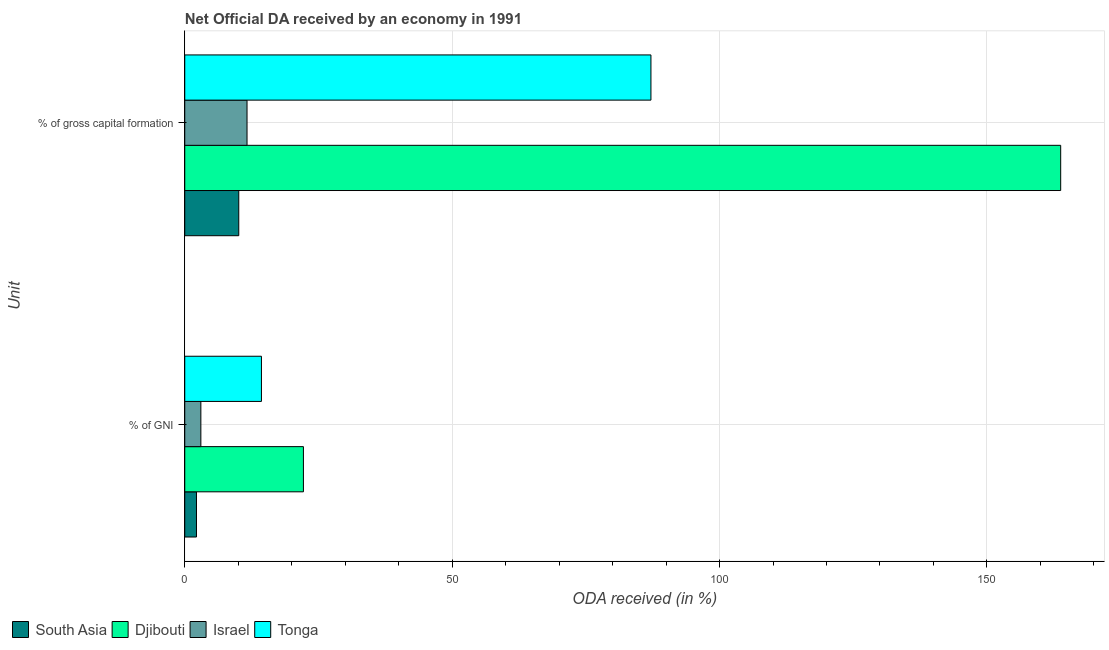How many groups of bars are there?
Offer a terse response. 2. Are the number of bars per tick equal to the number of legend labels?
Provide a succinct answer. Yes. Are the number of bars on each tick of the Y-axis equal?
Ensure brevity in your answer.  Yes. What is the label of the 1st group of bars from the top?
Provide a succinct answer. % of gross capital formation. What is the oda received as percentage of gni in South Asia?
Your answer should be very brief. 2.19. Across all countries, what is the maximum oda received as percentage of gross capital formation?
Your answer should be very brief. 163.8. Across all countries, what is the minimum oda received as percentage of gni?
Keep it short and to the point. 2.19. In which country was the oda received as percentage of gni maximum?
Your answer should be compact. Djibouti. What is the total oda received as percentage of gross capital formation in the graph?
Ensure brevity in your answer.  272.72. What is the difference between the oda received as percentage of gross capital formation in Tonga and that in Israel?
Your answer should be compact. 75.53. What is the difference between the oda received as percentage of gni in South Asia and the oda received as percentage of gross capital formation in Tonga?
Make the answer very short. -84.98. What is the average oda received as percentage of gross capital formation per country?
Offer a very short reply. 68.18. What is the difference between the oda received as percentage of gross capital formation and oda received as percentage of gni in Tonga?
Your response must be concise. 72.83. What is the ratio of the oda received as percentage of gross capital formation in Tonga to that in South Asia?
Make the answer very short. 8.63. Is the oda received as percentage of gross capital formation in Israel less than that in Tonga?
Provide a short and direct response. Yes. In how many countries, is the oda received as percentage of gni greater than the average oda received as percentage of gni taken over all countries?
Your answer should be compact. 2. What does the 4th bar from the bottom in % of GNI represents?
Keep it short and to the point. Tonga. How many bars are there?
Keep it short and to the point. 8. What is the difference between two consecutive major ticks on the X-axis?
Give a very brief answer. 50. Does the graph contain any zero values?
Your answer should be compact. No. Where does the legend appear in the graph?
Make the answer very short. Bottom left. How are the legend labels stacked?
Your answer should be compact. Horizontal. What is the title of the graph?
Provide a succinct answer. Net Official DA received by an economy in 1991. Does "Somalia" appear as one of the legend labels in the graph?
Offer a very short reply. No. What is the label or title of the X-axis?
Keep it short and to the point. ODA received (in %). What is the label or title of the Y-axis?
Offer a terse response. Unit. What is the ODA received (in %) in South Asia in % of GNI?
Give a very brief answer. 2.19. What is the ODA received (in %) of Djibouti in % of GNI?
Make the answer very short. 22.19. What is the ODA received (in %) in Israel in % of GNI?
Offer a terse response. 3.01. What is the ODA received (in %) in Tonga in % of GNI?
Offer a terse response. 14.34. What is the ODA received (in %) of South Asia in % of gross capital formation?
Your answer should be compact. 10.1. What is the ODA received (in %) in Djibouti in % of gross capital formation?
Offer a very short reply. 163.8. What is the ODA received (in %) of Israel in % of gross capital formation?
Make the answer very short. 11.64. What is the ODA received (in %) in Tonga in % of gross capital formation?
Keep it short and to the point. 87.18. Across all Unit, what is the maximum ODA received (in %) in South Asia?
Your answer should be compact. 10.1. Across all Unit, what is the maximum ODA received (in %) in Djibouti?
Offer a very short reply. 163.8. Across all Unit, what is the maximum ODA received (in %) of Israel?
Your answer should be compact. 11.64. Across all Unit, what is the maximum ODA received (in %) of Tonga?
Your answer should be compact. 87.18. Across all Unit, what is the minimum ODA received (in %) in South Asia?
Make the answer very short. 2.19. Across all Unit, what is the minimum ODA received (in %) of Djibouti?
Make the answer very short. 22.19. Across all Unit, what is the minimum ODA received (in %) of Israel?
Provide a succinct answer. 3.01. Across all Unit, what is the minimum ODA received (in %) of Tonga?
Ensure brevity in your answer.  14.34. What is the total ODA received (in %) of South Asia in the graph?
Your answer should be very brief. 12.29. What is the total ODA received (in %) in Djibouti in the graph?
Offer a terse response. 185.99. What is the total ODA received (in %) in Israel in the graph?
Provide a short and direct response. 14.66. What is the total ODA received (in %) in Tonga in the graph?
Offer a very short reply. 101.52. What is the difference between the ODA received (in %) in South Asia in % of GNI and that in % of gross capital formation?
Your answer should be very brief. -7.91. What is the difference between the ODA received (in %) in Djibouti in % of GNI and that in % of gross capital formation?
Offer a very short reply. -141.61. What is the difference between the ODA received (in %) in Israel in % of GNI and that in % of gross capital formation?
Give a very brief answer. -8.63. What is the difference between the ODA received (in %) of Tonga in % of GNI and that in % of gross capital formation?
Ensure brevity in your answer.  -72.83. What is the difference between the ODA received (in %) of South Asia in % of GNI and the ODA received (in %) of Djibouti in % of gross capital formation?
Keep it short and to the point. -161.6. What is the difference between the ODA received (in %) of South Asia in % of GNI and the ODA received (in %) of Israel in % of gross capital formation?
Your answer should be very brief. -9.45. What is the difference between the ODA received (in %) of South Asia in % of GNI and the ODA received (in %) of Tonga in % of gross capital formation?
Your answer should be very brief. -84.98. What is the difference between the ODA received (in %) in Djibouti in % of GNI and the ODA received (in %) in Israel in % of gross capital formation?
Your answer should be very brief. 10.55. What is the difference between the ODA received (in %) in Djibouti in % of GNI and the ODA received (in %) in Tonga in % of gross capital formation?
Offer a terse response. -64.98. What is the difference between the ODA received (in %) in Israel in % of GNI and the ODA received (in %) in Tonga in % of gross capital formation?
Ensure brevity in your answer.  -84.16. What is the average ODA received (in %) of South Asia per Unit?
Offer a very short reply. 6.15. What is the average ODA received (in %) in Djibouti per Unit?
Your answer should be very brief. 92.99. What is the average ODA received (in %) of Israel per Unit?
Provide a short and direct response. 7.33. What is the average ODA received (in %) in Tonga per Unit?
Provide a short and direct response. 50.76. What is the difference between the ODA received (in %) of South Asia and ODA received (in %) of Djibouti in % of GNI?
Ensure brevity in your answer.  -20. What is the difference between the ODA received (in %) of South Asia and ODA received (in %) of Israel in % of GNI?
Keep it short and to the point. -0.82. What is the difference between the ODA received (in %) in South Asia and ODA received (in %) in Tonga in % of GNI?
Give a very brief answer. -12.15. What is the difference between the ODA received (in %) of Djibouti and ODA received (in %) of Israel in % of GNI?
Your response must be concise. 19.18. What is the difference between the ODA received (in %) of Djibouti and ODA received (in %) of Tonga in % of GNI?
Keep it short and to the point. 7.85. What is the difference between the ODA received (in %) of Israel and ODA received (in %) of Tonga in % of GNI?
Your response must be concise. -11.33. What is the difference between the ODA received (in %) of South Asia and ODA received (in %) of Djibouti in % of gross capital formation?
Your answer should be compact. -153.7. What is the difference between the ODA received (in %) in South Asia and ODA received (in %) in Israel in % of gross capital formation?
Ensure brevity in your answer.  -1.54. What is the difference between the ODA received (in %) of South Asia and ODA received (in %) of Tonga in % of gross capital formation?
Make the answer very short. -77.07. What is the difference between the ODA received (in %) in Djibouti and ODA received (in %) in Israel in % of gross capital formation?
Provide a succinct answer. 152.15. What is the difference between the ODA received (in %) of Djibouti and ODA received (in %) of Tonga in % of gross capital formation?
Make the answer very short. 76.62. What is the difference between the ODA received (in %) of Israel and ODA received (in %) of Tonga in % of gross capital formation?
Give a very brief answer. -75.53. What is the ratio of the ODA received (in %) of South Asia in % of GNI to that in % of gross capital formation?
Make the answer very short. 0.22. What is the ratio of the ODA received (in %) in Djibouti in % of GNI to that in % of gross capital formation?
Your response must be concise. 0.14. What is the ratio of the ODA received (in %) in Israel in % of GNI to that in % of gross capital formation?
Your response must be concise. 0.26. What is the ratio of the ODA received (in %) of Tonga in % of GNI to that in % of gross capital formation?
Provide a short and direct response. 0.16. What is the difference between the highest and the second highest ODA received (in %) in South Asia?
Offer a terse response. 7.91. What is the difference between the highest and the second highest ODA received (in %) of Djibouti?
Offer a very short reply. 141.61. What is the difference between the highest and the second highest ODA received (in %) of Israel?
Provide a short and direct response. 8.63. What is the difference between the highest and the second highest ODA received (in %) in Tonga?
Your answer should be very brief. 72.83. What is the difference between the highest and the lowest ODA received (in %) of South Asia?
Make the answer very short. 7.91. What is the difference between the highest and the lowest ODA received (in %) in Djibouti?
Ensure brevity in your answer.  141.61. What is the difference between the highest and the lowest ODA received (in %) of Israel?
Provide a succinct answer. 8.63. What is the difference between the highest and the lowest ODA received (in %) in Tonga?
Your response must be concise. 72.83. 